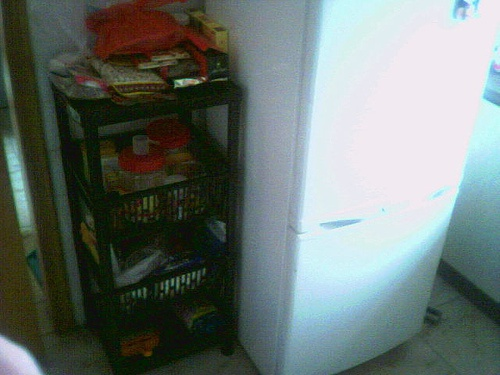Describe the objects in this image and their specific colors. I can see a refrigerator in black, white, darkgray, and gray tones in this image. 